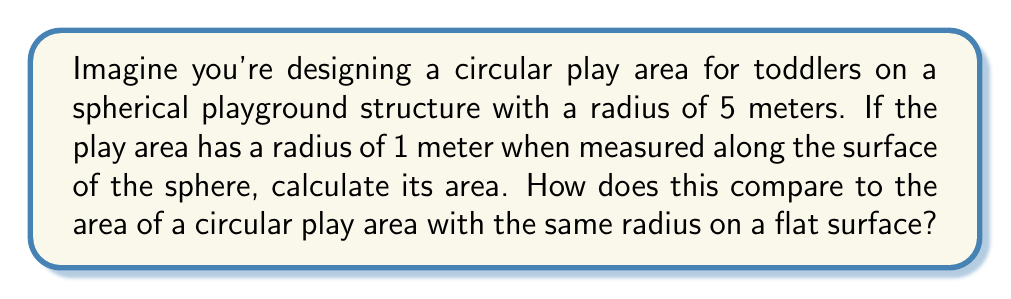Could you help me with this problem? Let's approach this step-by-step:

1) For a circle on a sphere (spherical cap), we use the formula:
   $$A = 2\pi Rh$$
   where $R$ is the radius of the sphere and $h$ is the height of the cap.

2) To find $h$, we need to use the relationship between the arc length $s$ (which is our 1-meter radius along the surface) and the central angle $\theta$:
   $$s = R\theta$$
   $$1 = 5\theta$$
   $$\theta = \frac{1}{5} \text{ radians}$$

3) Now we can find $h$ using:
   $$h = R(1 - \cos(\theta))$$
   $$h = 5(1 - \cos(\frac{1}{5})) \approx 0.0100 \text{ meters}$$

4) Plugging this into our area formula:
   $$A = 2\pi(5)(0.0100) \approx 0.3142 \text{ square meters}$$

5) For a flat circle, the area would be:
   $$A = \pi r^2 = \pi(1^2) = \pi \approx 3.1416 \text{ square meters}$$

6) The ratio of the spherical area to the flat area is:
   $$\frac{0.3142}{3.1416} \approx 0.1000 \text{ or } 10\%$$

[asy]
import geometry;

size(200);
draw(circle((0,0),5), blue);
draw(arc((0,0),5,80,100), red+1);
draw((0,0)--(5*cos(90),5*sin(90)), dashed);
draw((0,0)--(5*cos(80),5*sin(80)), dashed);
label("R=5m", (2.5,0), S);
label("1m", (5*cos(85),5*sin(85)), NE);
[/asy]
Answer: Spherical area: 0.3142 m², 10% of flat area 